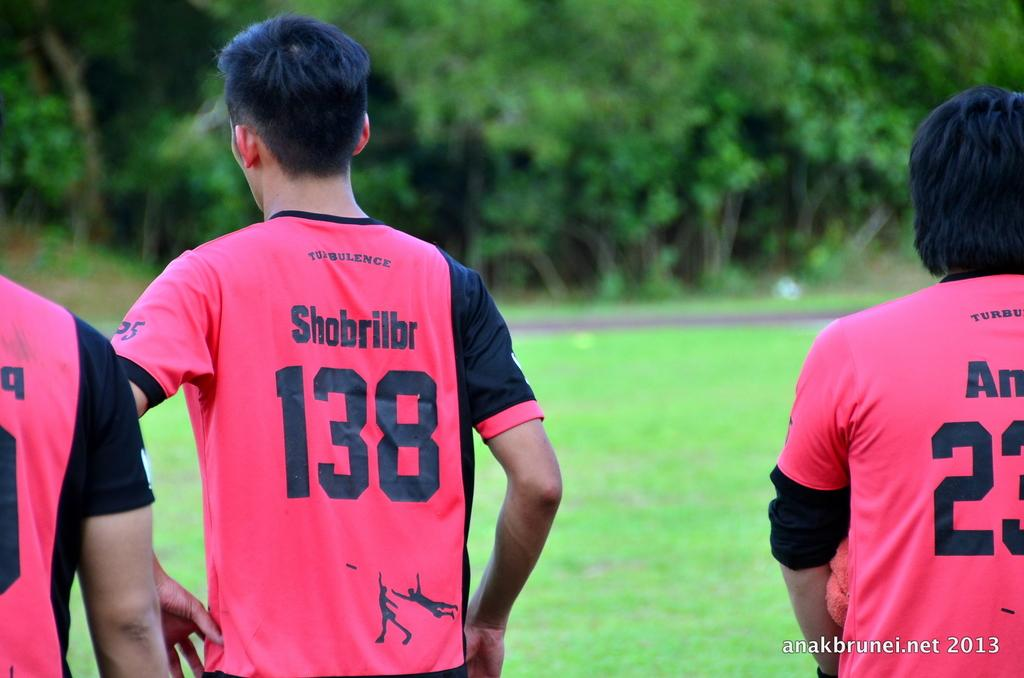<image>
Summarize the visual content of the image. Soccer Athletes in a line with number 138 in the middle and number 23 on the right. 